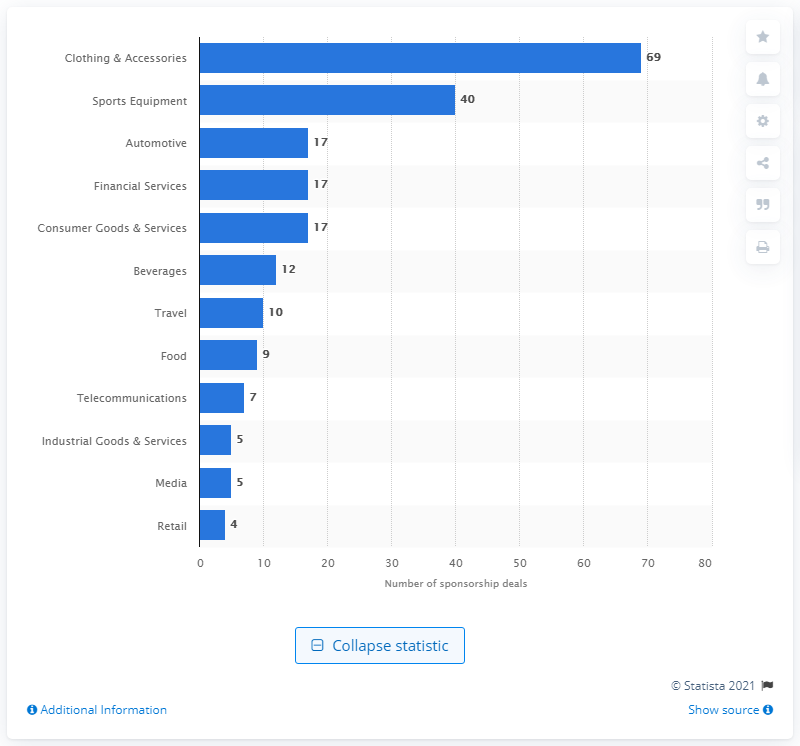Outline some significant characteristics in this image. There were 69 sponsorship deals between clothing and accessories brands and tennis players. 